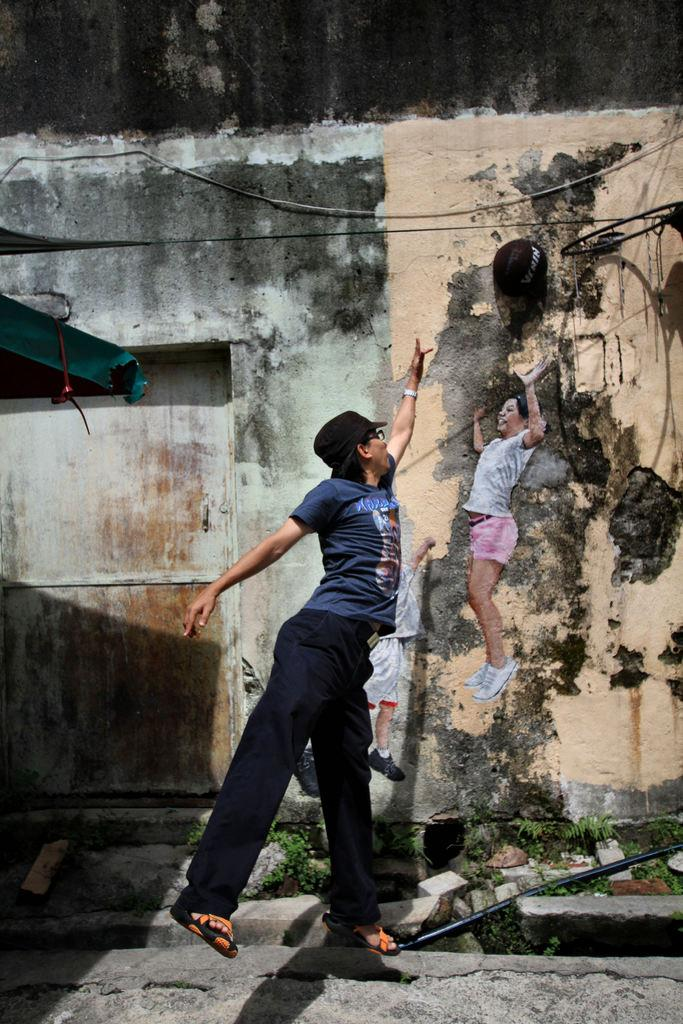What is the person in the image doing? The person is standing on the path in the image. What can be seen in the background of the image? There is grass, an iron rod, and a painting of two persons on the wall in the background of the image. What substance is the person using to unlock the door in the image? There is no door or lock present in the image, so the person is not using any substance to unlock anything. 